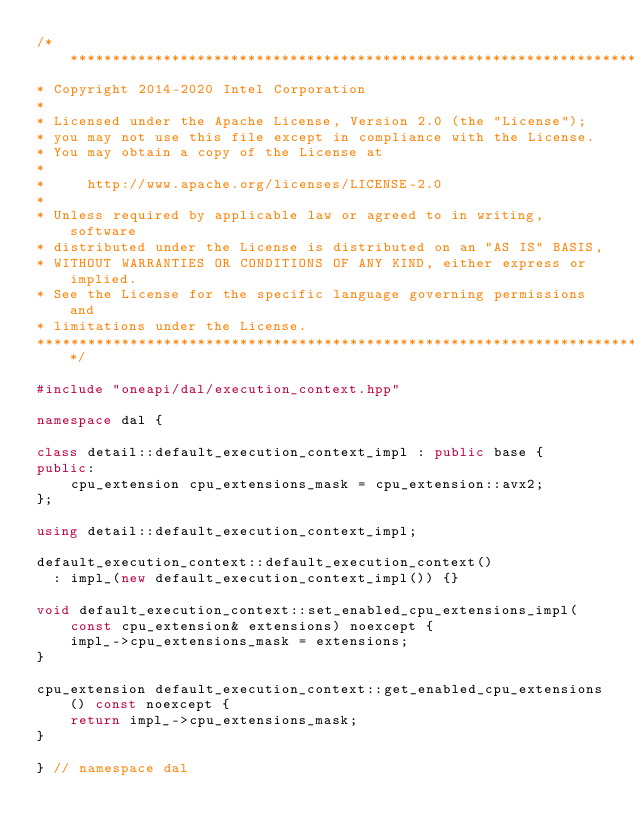<code> <loc_0><loc_0><loc_500><loc_500><_C++_>/*******************************************************************************
* Copyright 2014-2020 Intel Corporation
*
* Licensed under the Apache License, Version 2.0 (the "License");
* you may not use this file except in compliance with the License.
* You may obtain a copy of the License at
*
*     http://www.apache.org/licenses/LICENSE-2.0
*
* Unless required by applicable law or agreed to in writing, software
* distributed under the License is distributed on an "AS IS" BASIS,
* WITHOUT WARRANTIES OR CONDITIONS OF ANY KIND, either express or implied.
* See the License for the specific language governing permissions and
* limitations under the License.
*******************************************************************************/

#include "oneapi/dal/execution_context.hpp"

namespace dal {

class detail::default_execution_context_impl : public base {
public:
    cpu_extension cpu_extensions_mask = cpu_extension::avx2;
};

using detail::default_execution_context_impl;

default_execution_context::default_execution_context()
  : impl_(new default_execution_context_impl()) {}

void default_execution_context::set_enabled_cpu_extensions_impl(
    const cpu_extension& extensions) noexcept {
    impl_->cpu_extensions_mask = extensions;
}

cpu_extension default_execution_context::get_enabled_cpu_extensions() const noexcept {
    return impl_->cpu_extensions_mask;
}

} // namespace dal
</code> 